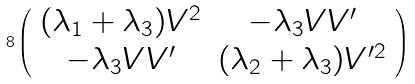<formula> <loc_0><loc_0><loc_500><loc_500>8 \left ( \begin{array} { c c } ( \lambda _ { 1 } + \lambda _ { 3 } ) V ^ { 2 } & - \lambda _ { 3 } V V ^ { \prime } \\ - \lambda _ { 3 } V V ^ { \prime } & ( \lambda _ { 2 } + \lambda _ { 3 } ) V ^ { \prime 2 } \end{array} \right )</formula> 